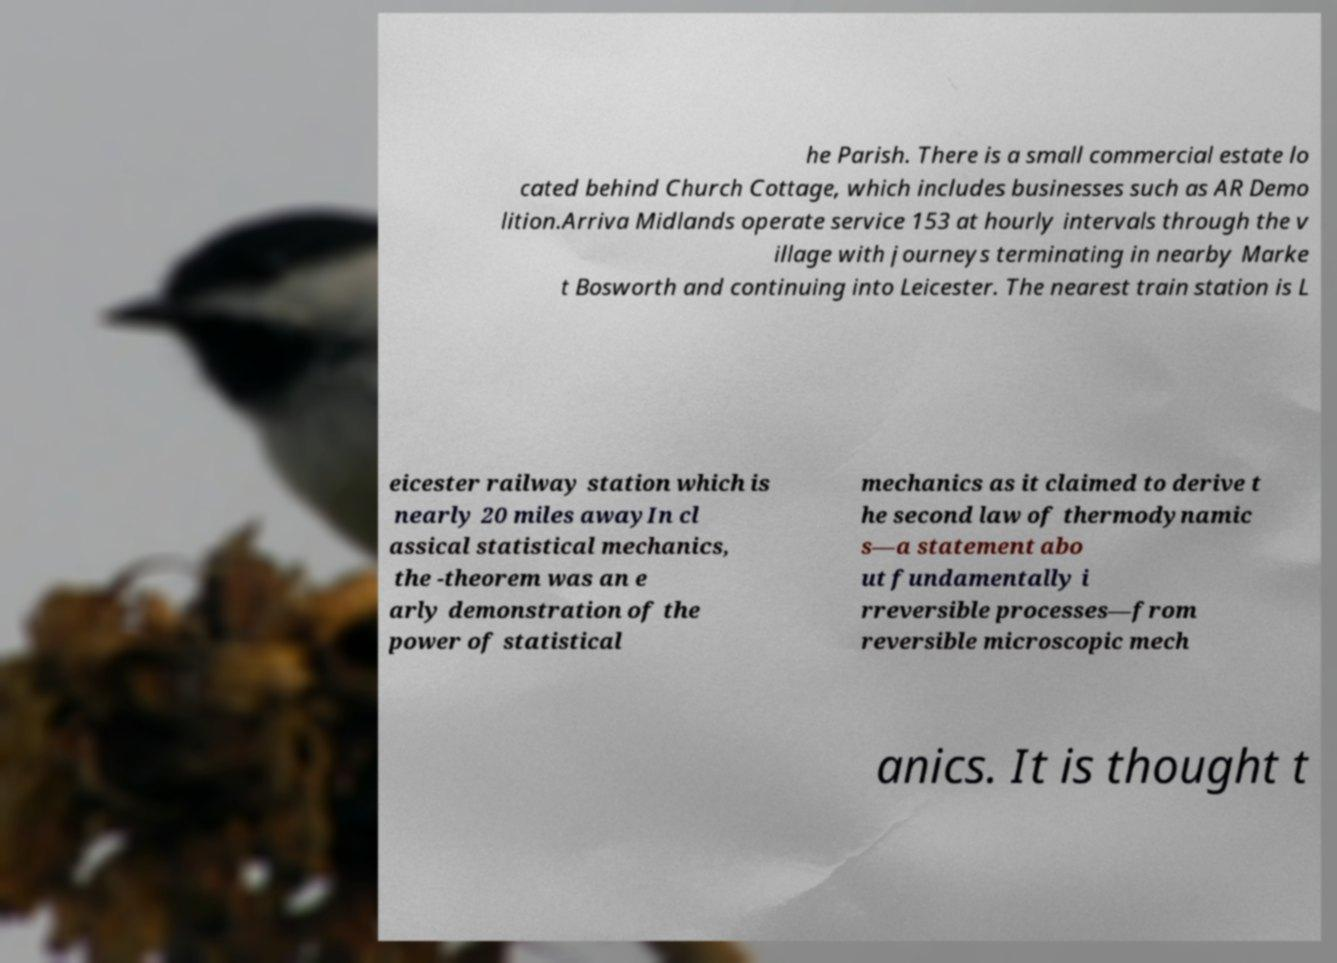Could you extract and type out the text from this image? he Parish. There is a small commercial estate lo cated behind Church Cottage, which includes businesses such as AR Demo lition.Arriva Midlands operate service 153 at hourly intervals through the v illage with journeys terminating in nearby Marke t Bosworth and continuing into Leicester. The nearest train station is L eicester railway station which is nearly 20 miles awayIn cl assical statistical mechanics, the -theorem was an e arly demonstration of the power of statistical mechanics as it claimed to derive t he second law of thermodynamic s—a statement abo ut fundamentally i rreversible processes—from reversible microscopic mech anics. It is thought t 